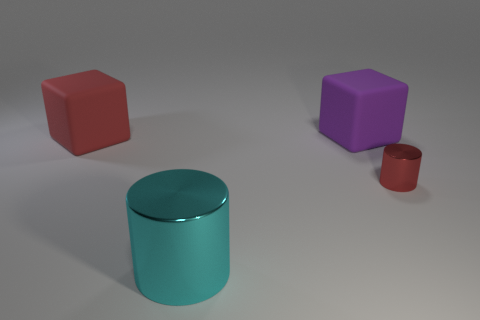Add 2 tiny gray matte balls. How many objects exist? 6 Add 1 purple cubes. How many purple cubes are left? 2 Add 4 tiny red cylinders. How many tiny red cylinders exist? 5 Subtract 0 gray cylinders. How many objects are left? 4 Subtract all gray shiny cylinders. Subtract all cylinders. How many objects are left? 2 